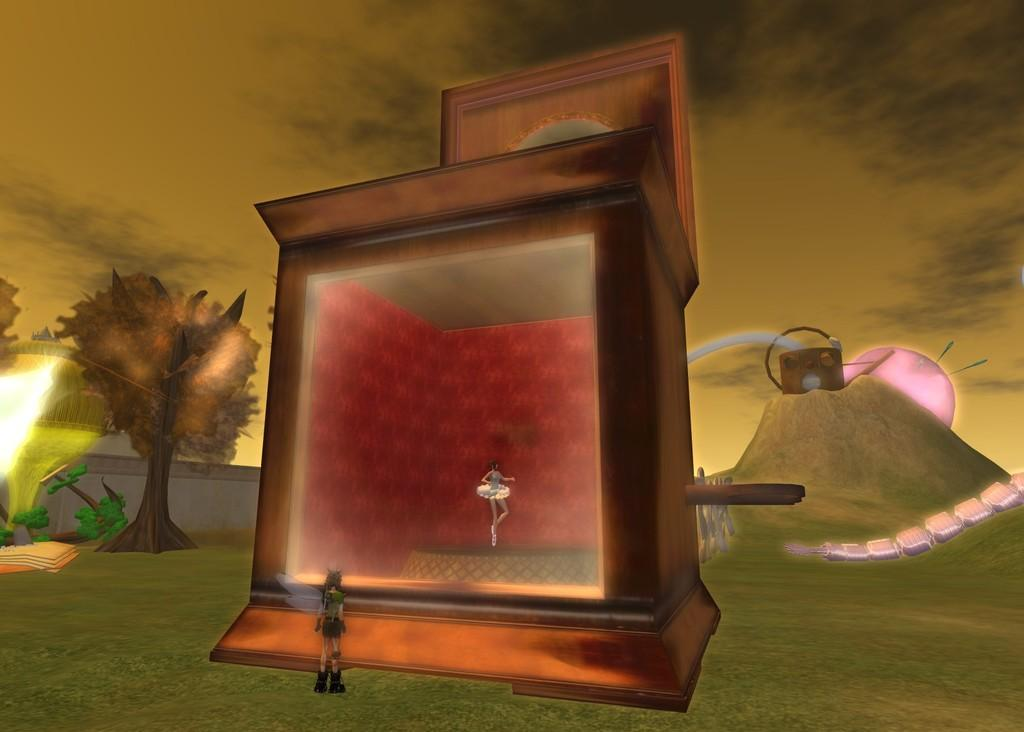How many people are in the image? There are two persons standing in the image. What can be seen in the background of the image? There are trees visible in the image, and the background has a pink light. What is visible at the top of the image? The sky is visible in the image. What object is present in front of the scene? There is a box in front of the scene. How many toys are on the ground in the image? There are no toys visible in the image. Are there any women in the image? The provided facts do not specify the gender of the two persons in the image, so we cannot definitively answer whether there are any women present. 